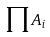Convert formula to latex. <formula><loc_0><loc_0><loc_500><loc_500>\prod A _ { i }</formula> 